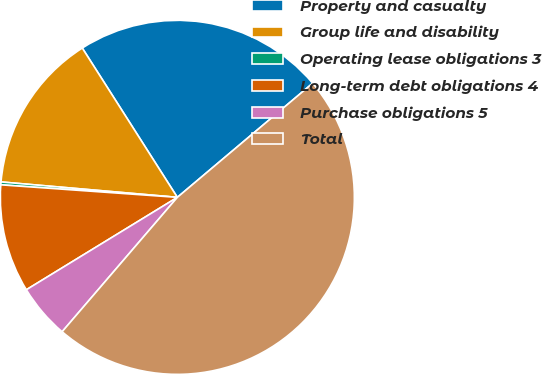Convert chart. <chart><loc_0><loc_0><loc_500><loc_500><pie_chart><fcel>Property and casualty<fcel>Group life and disability<fcel>Operating lease obligations 3<fcel>Long-term debt obligations 4<fcel>Purchase obligations 5<fcel>Total<nl><fcel>22.88%<fcel>14.59%<fcel>0.26%<fcel>9.87%<fcel>4.98%<fcel>47.44%<nl></chart> 